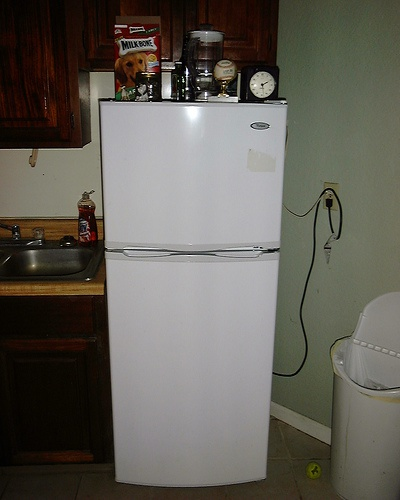Describe the objects in this image and their specific colors. I can see refrigerator in black, darkgray, and gray tones, sink in black and gray tones, bottle in black, gray, lightgray, and darkgray tones, clock in black, darkgray, and gray tones, and bottle in black, maroon, and gray tones in this image. 